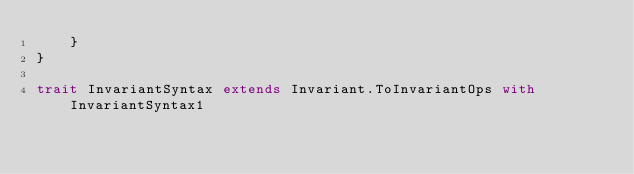<code> <loc_0><loc_0><loc_500><loc_500><_Scala_>    }
}

trait InvariantSyntax extends Invariant.ToInvariantOps with InvariantSyntax1
</code> 